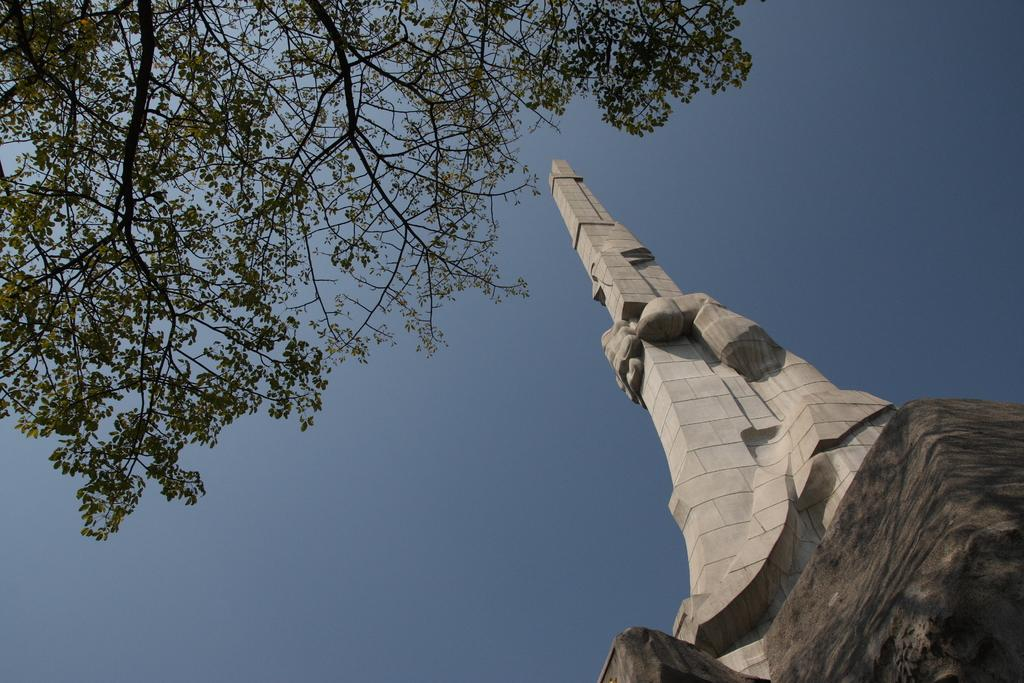What type of structure is located on the right side of the image? There is a stone tower on the right side of the image. What type of vegetation is on the left side of the image? There is a tree visible on the left side of the image. What is the color of the sky in the image? The sky is blue in color. How many items are on the list in the image? There is no list present in the image. Can you describe the digestion process of the tree in the image? There is no digestion process for the tree in the image, as trees do not have digestive systems. 